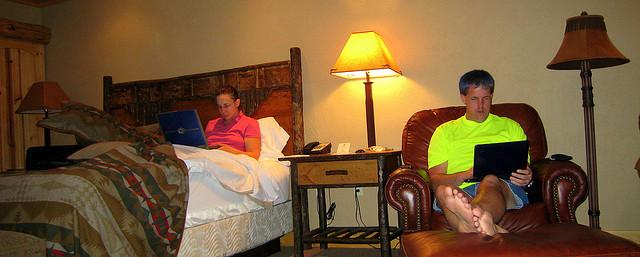Why are they so far apart? working 